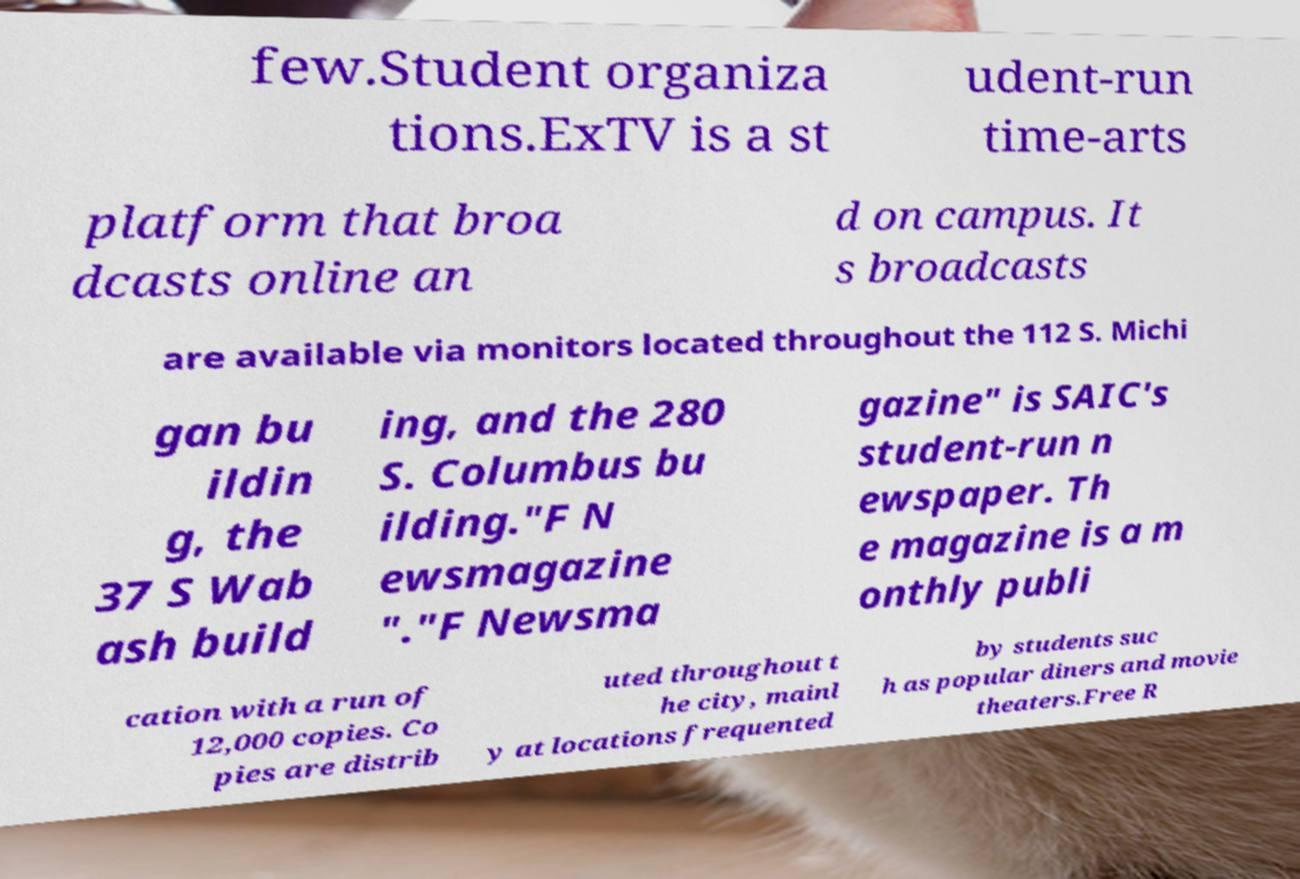Can you accurately transcribe the text from the provided image for me? few.Student organiza tions.ExTV is a st udent-run time-arts platform that broa dcasts online an d on campus. It s broadcasts are available via monitors located throughout the 112 S. Michi gan bu ildin g, the 37 S Wab ash build ing, and the 280 S. Columbus bu ilding."F N ewsmagazine "."F Newsma gazine" is SAIC's student-run n ewspaper. Th e magazine is a m onthly publi cation with a run of 12,000 copies. Co pies are distrib uted throughout t he city, mainl y at locations frequented by students suc h as popular diners and movie theaters.Free R 